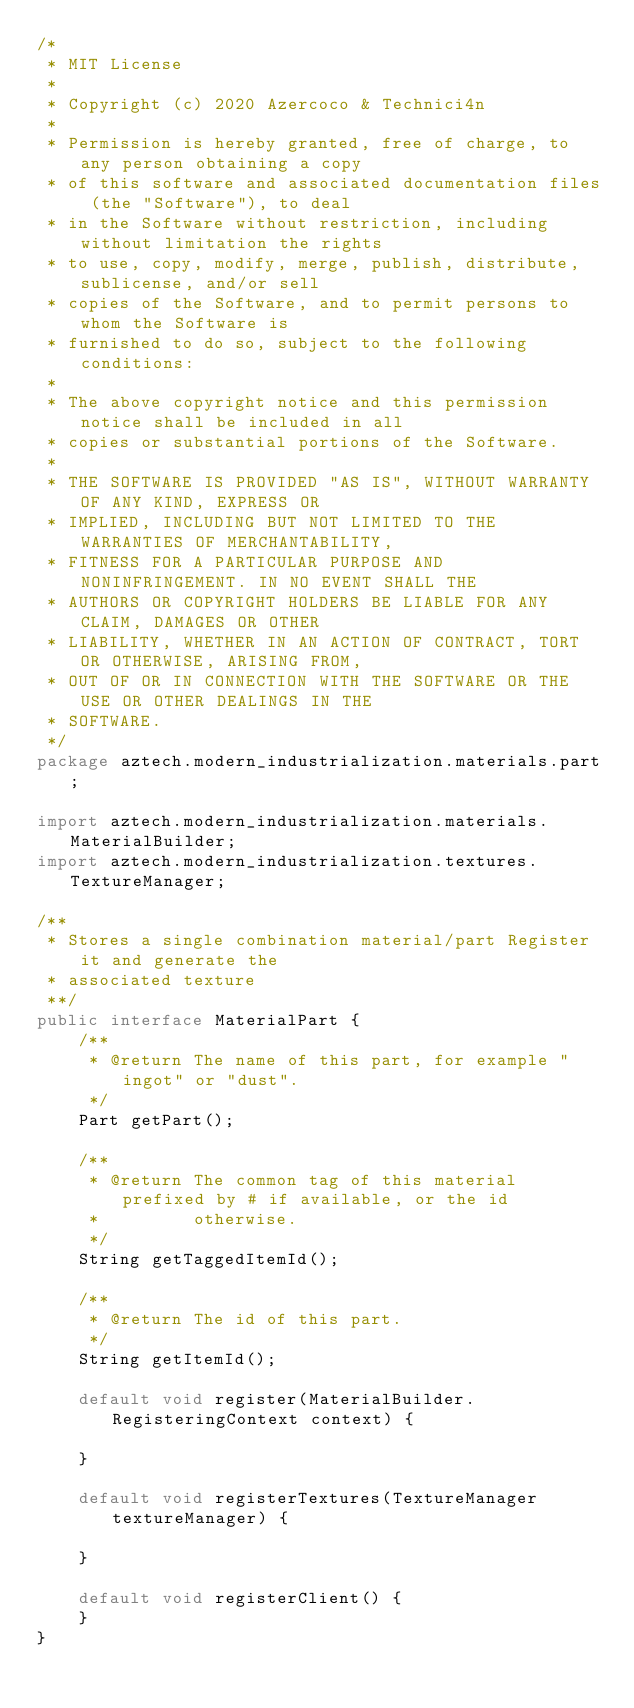<code> <loc_0><loc_0><loc_500><loc_500><_Java_>/*
 * MIT License
 *
 * Copyright (c) 2020 Azercoco & Technici4n
 *
 * Permission is hereby granted, free of charge, to any person obtaining a copy
 * of this software and associated documentation files (the "Software"), to deal
 * in the Software without restriction, including without limitation the rights
 * to use, copy, modify, merge, publish, distribute, sublicense, and/or sell
 * copies of the Software, and to permit persons to whom the Software is
 * furnished to do so, subject to the following conditions:
 *
 * The above copyright notice and this permission notice shall be included in all
 * copies or substantial portions of the Software.
 *
 * THE SOFTWARE IS PROVIDED "AS IS", WITHOUT WARRANTY OF ANY KIND, EXPRESS OR
 * IMPLIED, INCLUDING BUT NOT LIMITED TO THE WARRANTIES OF MERCHANTABILITY,
 * FITNESS FOR A PARTICULAR PURPOSE AND NONINFRINGEMENT. IN NO EVENT SHALL THE
 * AUTHORS OR COPYRIGHT HOLDERS BE LIABLE FOR ANY CLAIM, DAMAGES OR OTHER
 * LIABILITY, WHETHER IN AN ACTION OF CONTRACT, TORT OR OTHERWISE, ARISING FROM,
 * OUT OF OR IN CONNECTION WITH THE SOFTWARE OR THE USE OR OTHER DEALINGS IN THE
 * SOFTWARE.
 */
package aztech.modern_industrialization.materials.part;

import aztech.modern_industrialization.materials.MaterialBuilder;
import aztech.modern_industrialization.textures.TextureManager;

/**
 * Stores a single combination material/part Register it and generate the
 * associated texture
 **/
public interface MaterialPart {
    /**
     * @return The name of this part, for example "ingot" or "dust".
     */
    Part getPart();

    /**
     * @return The common tag of this material prefixed by # if available, or the id
     *         otherwise.
     */
    String getTaggedItemId();

    /**
     * @return The id of this part.
     */
    String getItemId();

    default void register(MaterialBuilder.RegisteringContext context) {

    }

    default void registerTextures(TextureManager textureManager) {

    }

    default void registerClient() {
    }
}
</code> 